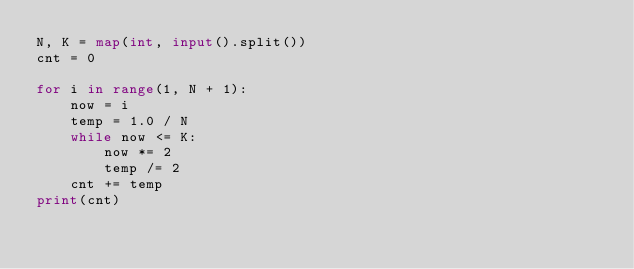<code> <loc_0><loc_0><loc_500><loc_500><_Python_>N, K = map(int, input().split())
cnt = 0

for i in range(1, N + 1):
    now = i
    temp = 1.0 / N
    while now <= K:
        now *= 2
        temp /= 2
    cnt += temp
print(cnt)
</code> 